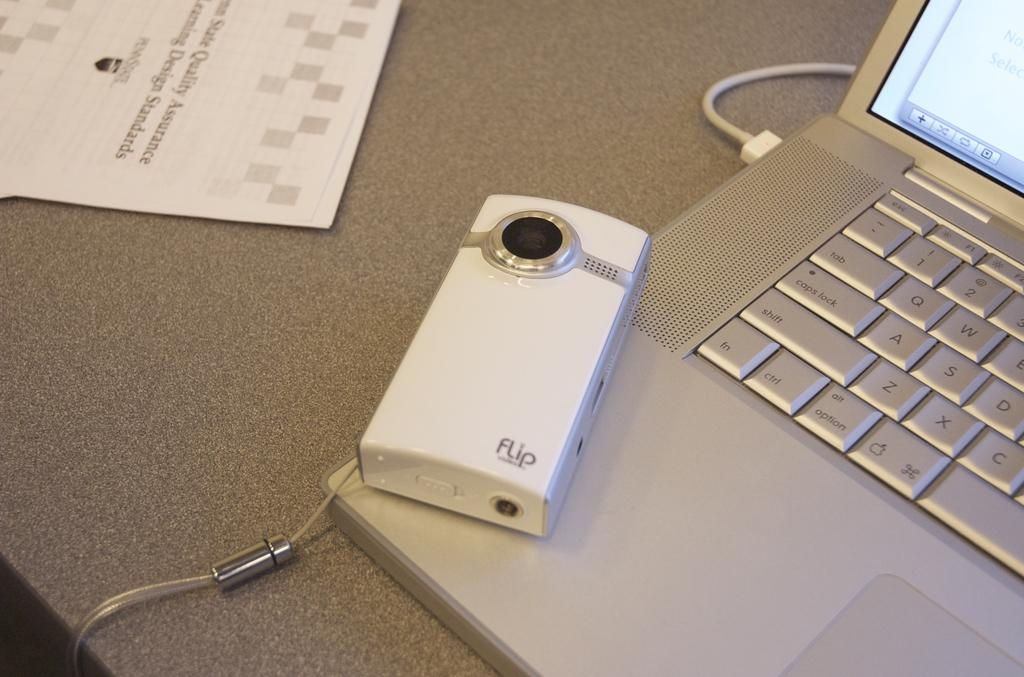<image>
Provide a brief description of the given image. white flip camera on top of a silver apple laptop 